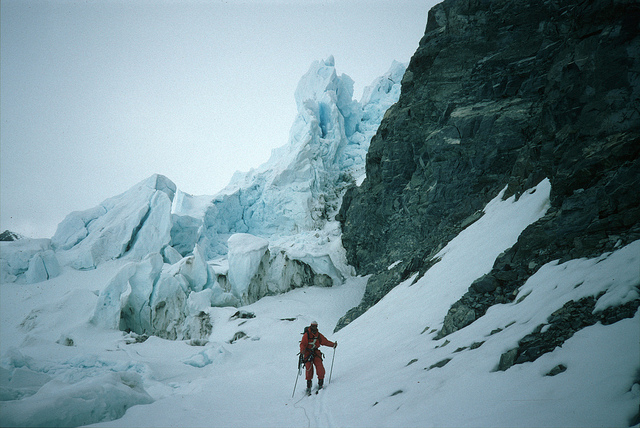<image>Which hand is raised in the air? No hand is raised in the air. Which hand is raised in the air? It is unclear from the image which hand is raised in the air. There are no hands in the air in the image. 